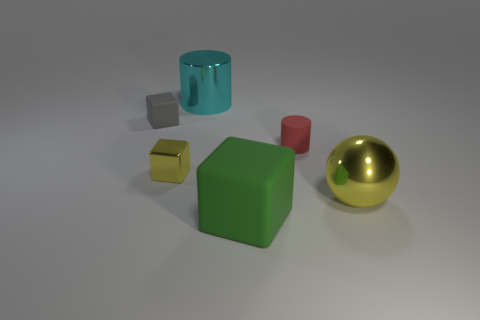Add 1 tiny red cylinders. How many objects exist? 7 Subtract all yellow metal blocks. How many blocks are left? 2 Subtract all green blocks. How many blocks are left? 2 Subtract 0 purple blocks. How many objects are left? 6 Subtract all spheres. How many objects are left? 5 Subtract 1 cubes. How many cubes are left? 2 Subtract all cyan blocks. Subtract all yellow spheres. How many blocks are left? 3 Subtract all red blocks. How many green cylinders are left? 0 Subtract all big blocks. Subtract all metal cubes. How many objects are left? 4 Add 6 matte cylinders. How many matte cylinders are left? 7 